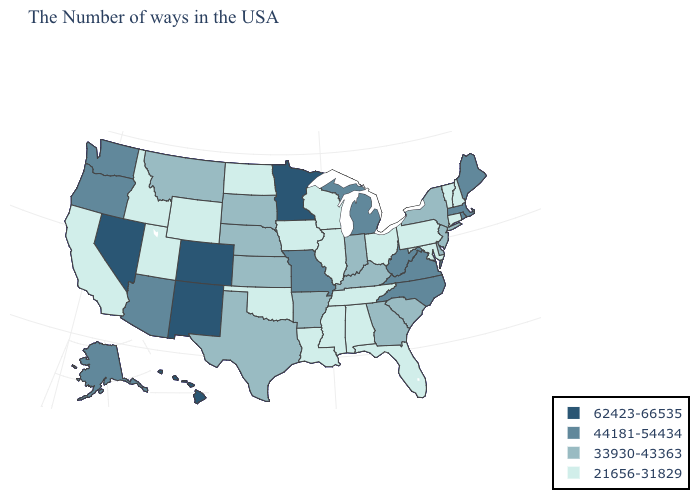Name the states that have a value in the range 62423-66535?
Answer briefly. Minnesota, Colorado, New Mexico, Nevada, Hawaii. What is the value of South Dakota?
Keep it brief. 33930-43363. Does the first symbol in the legend represent the smallest category?
Quick response, please. No. Name the states that have a value in the range 33930-43363?
Keep it brief. New York, New Jersey, Delaware, South Carolina, Georgia, Kentucky, Indiana, Arkansas, Kansas, Nebraska, Texas, South Dakota, Montana. Does Louisiana have the lowest value in the South?
Short answer required. Yes. What is the value of Indiana?
Give a very brief answer. 33930-43363. Does Minnesota have the highest value in the USA?
Give a very brief answer. Yes. Does the first symbol in the legend represent the smallest category?
Give a very brief answer. No. Does Wyoming have the lowest value in the USA?
Give a very brief answer. Yes. Among the states that border South Carolina , which have the lowest value?
Concise answer only. Georgia. Does the first symbol in the legend represent the smallest category?
Concise answer only. No. Does Virginia have the highest value in the USA?
Write a very short answer. No. Among the states that border Nebraska , which have the highest value?
Quick response, please. Colorado. Does Arkansas have the lowest value in the USA?
Answer briefly. No. 